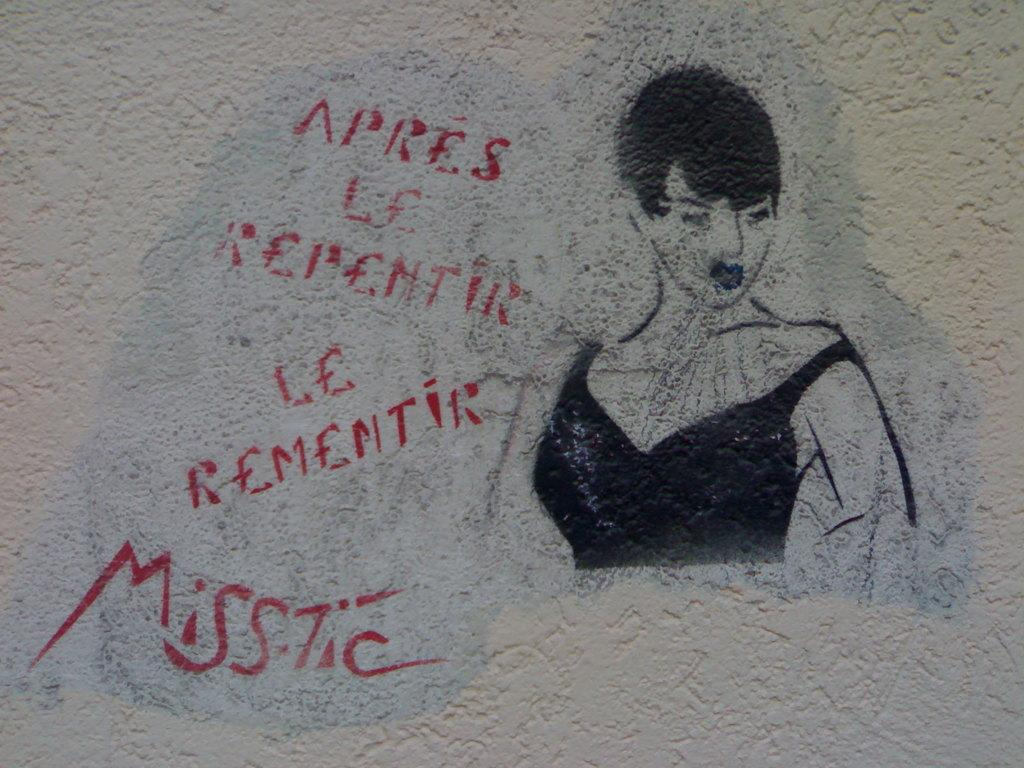What is present on the wall in the image? There is a painting of a lady on the wall. What is depicted in the painting? The painting is of a lady. Is there any text or writing in the image? Yes, there is something written to the side of the painting. What color is the cream used in the painting? There is no cream used in the painting, as it is a painting of a lady and not a food item. 